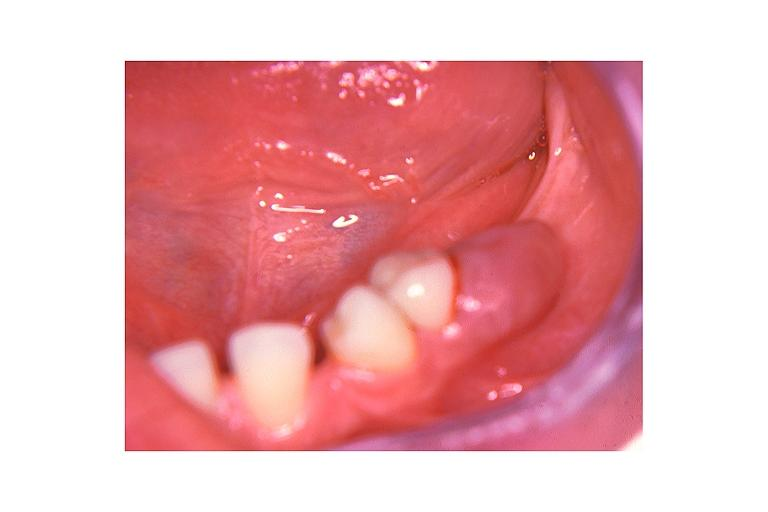does this image show peripheral giant cell lesion?
Answer the question using a single word or phrase. Yes 